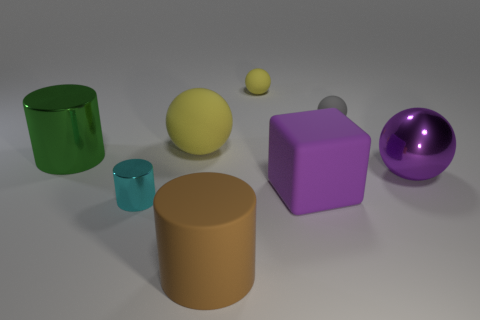Subtract all red cylinders. Subtract all cyan cubes. How many cylinders are left? 3 Add 1 large green matte balls. How many objects exist? 9 Subtract all cylinders. How many objects are left? 5 Subtract all big purple matte blocks. Subtract all large brown cylinders. How many objects are left? 6 Add 1 tiny cyan shiny objects. How many tiny cyan shiny objects are left? 2 Add 6 large green cylinders. How many large green cylinders exist? 7 Subtract 1 green cylinders. How many objects are left? 7 